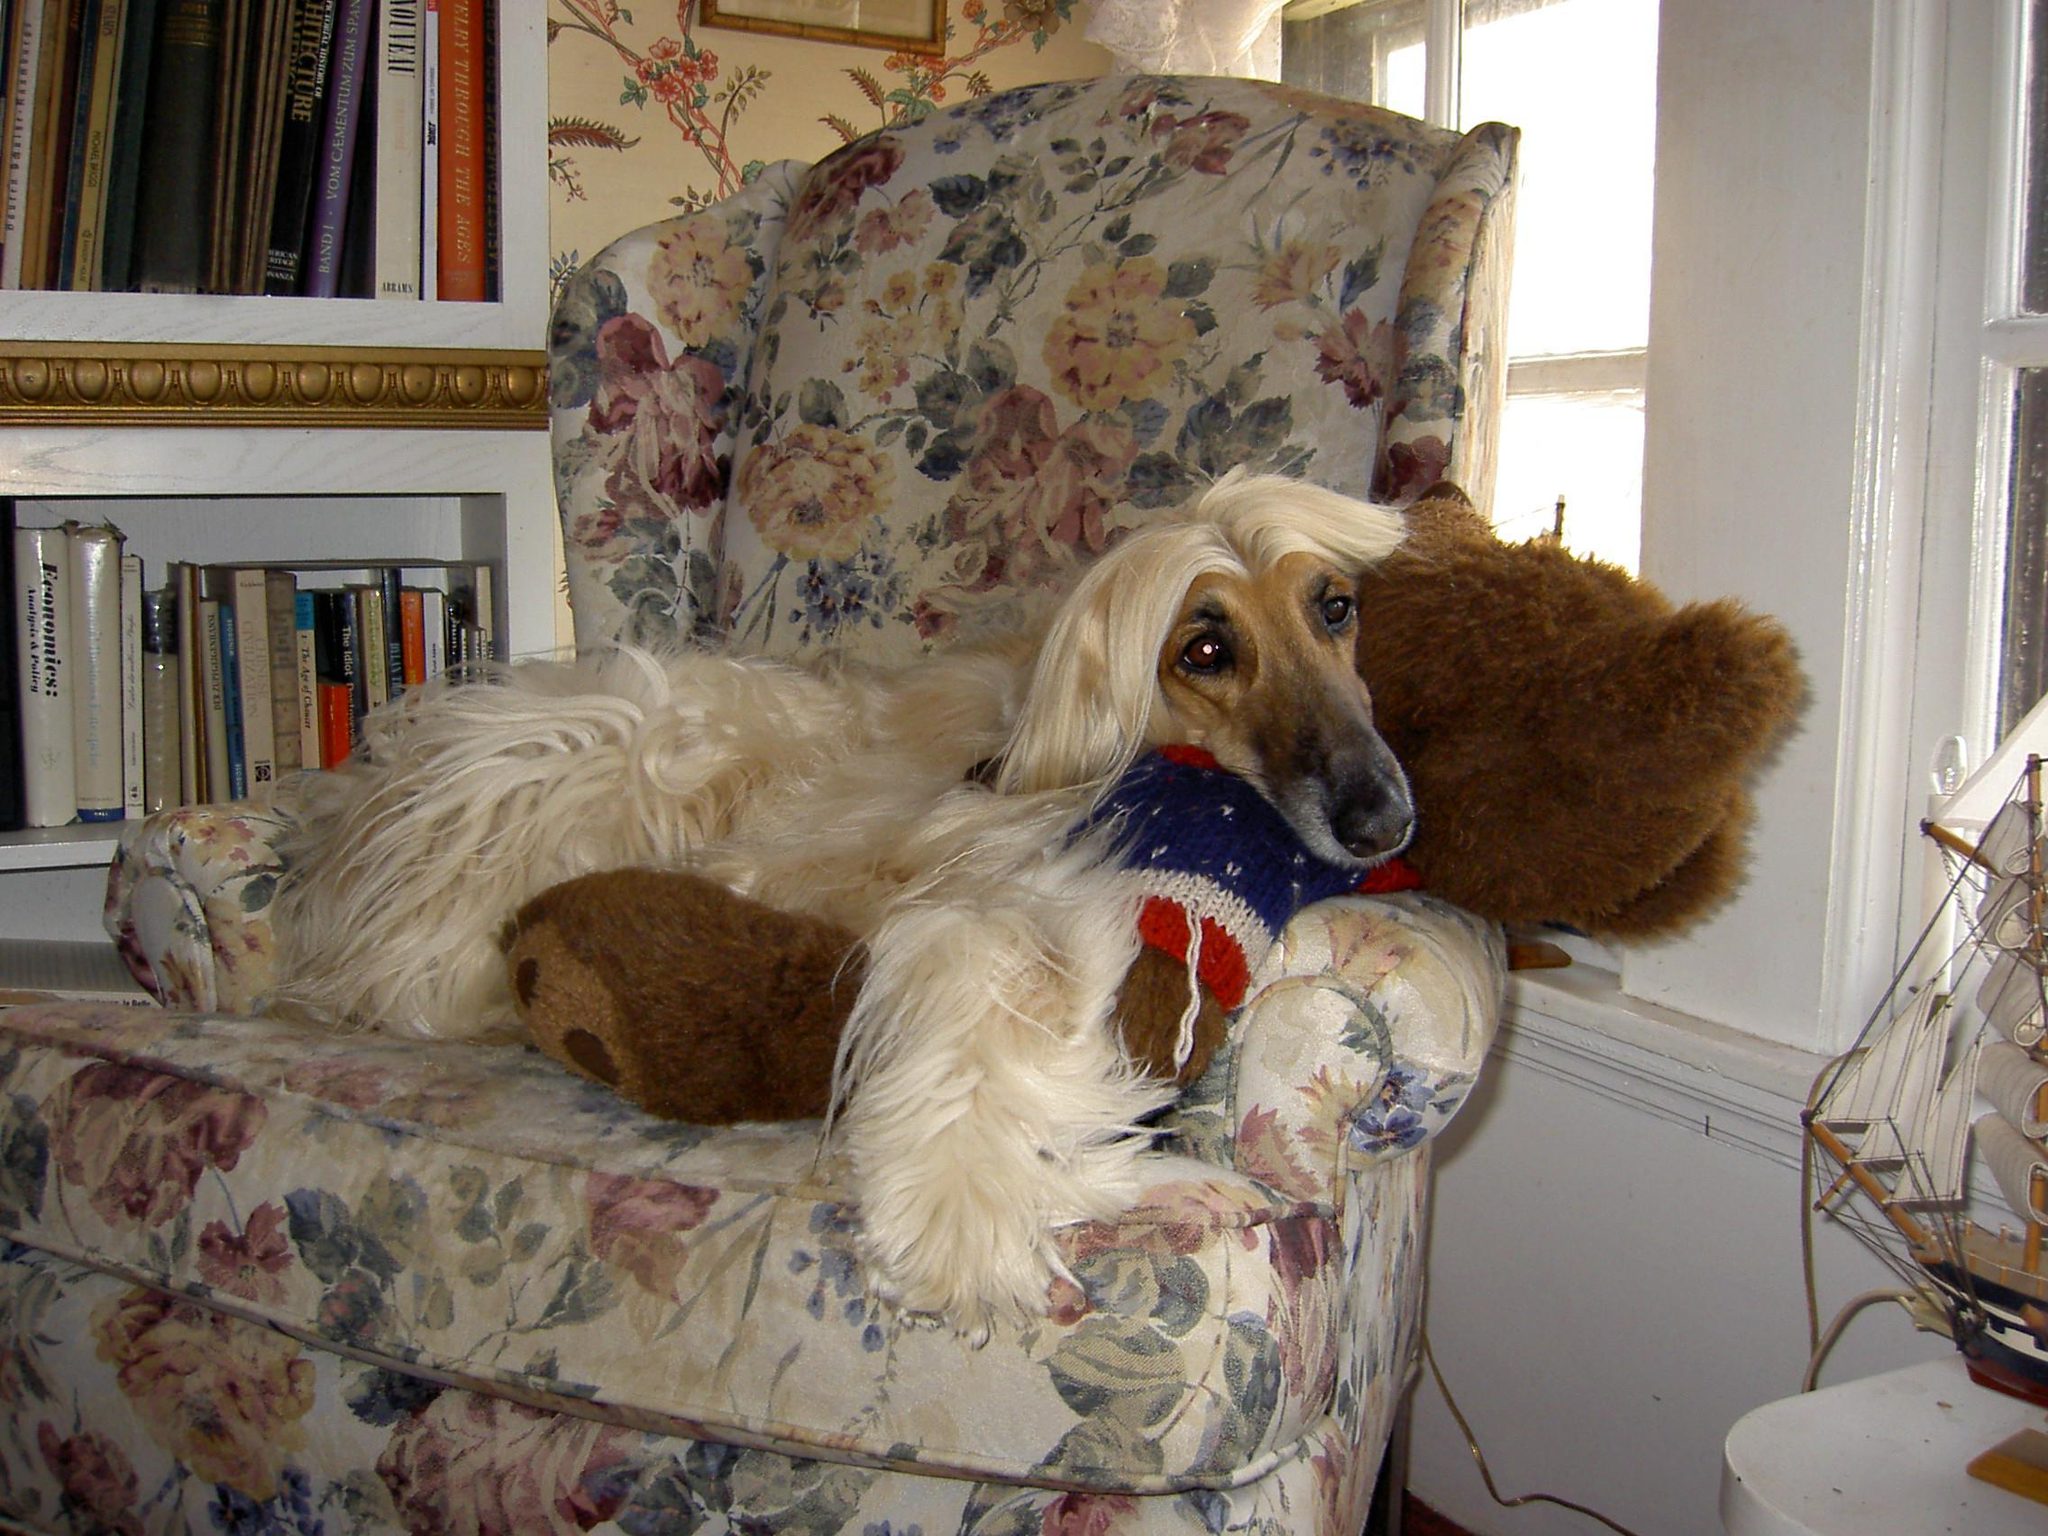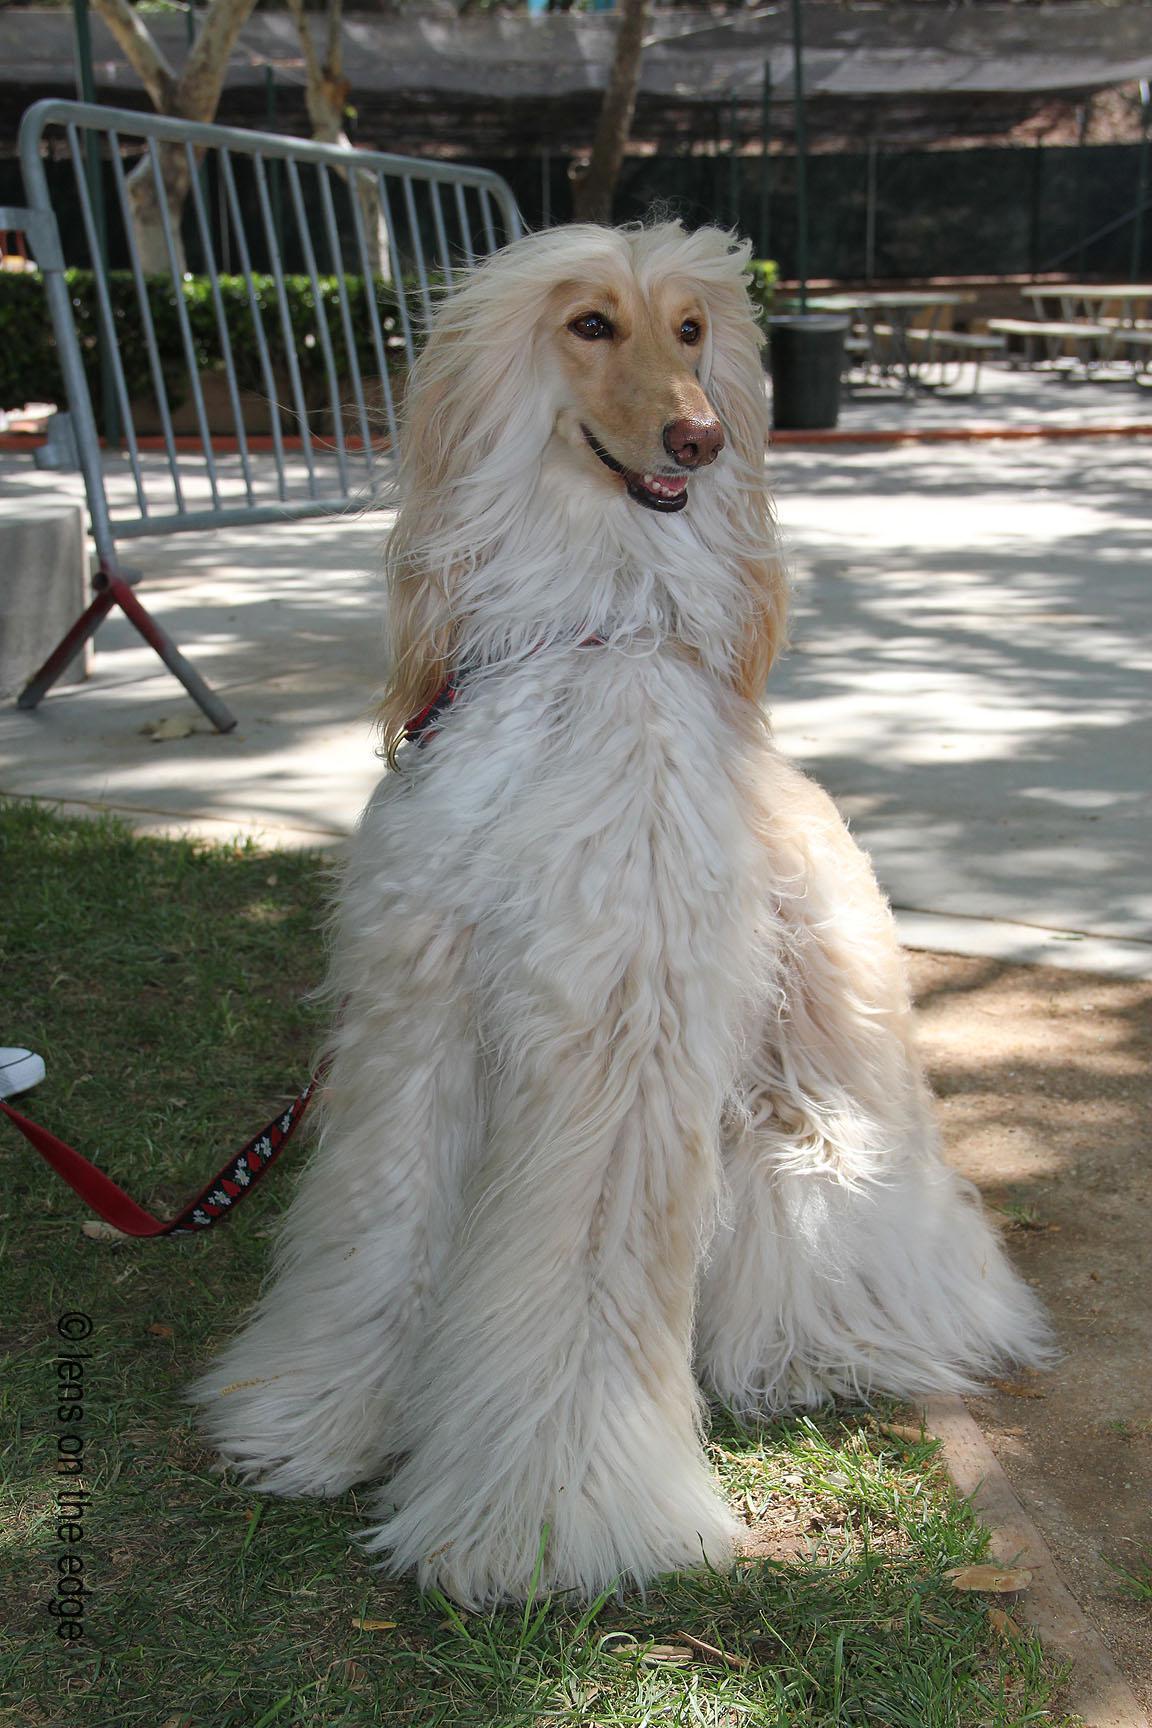The first image is the image on the left, the second image is the image on the right. Considering the images on both sides, is "Each image contains one afghan hound, all hounds are primarily light colored, and one hound sits upright while the other is reclining." valid? Answer yes or no. Yes. The first image is the image on the left, the second image is the image on the right. Examine the images to the left and right. Is the description "There are more dogs in the image on the left." accurate? Answer yes or no. No. 